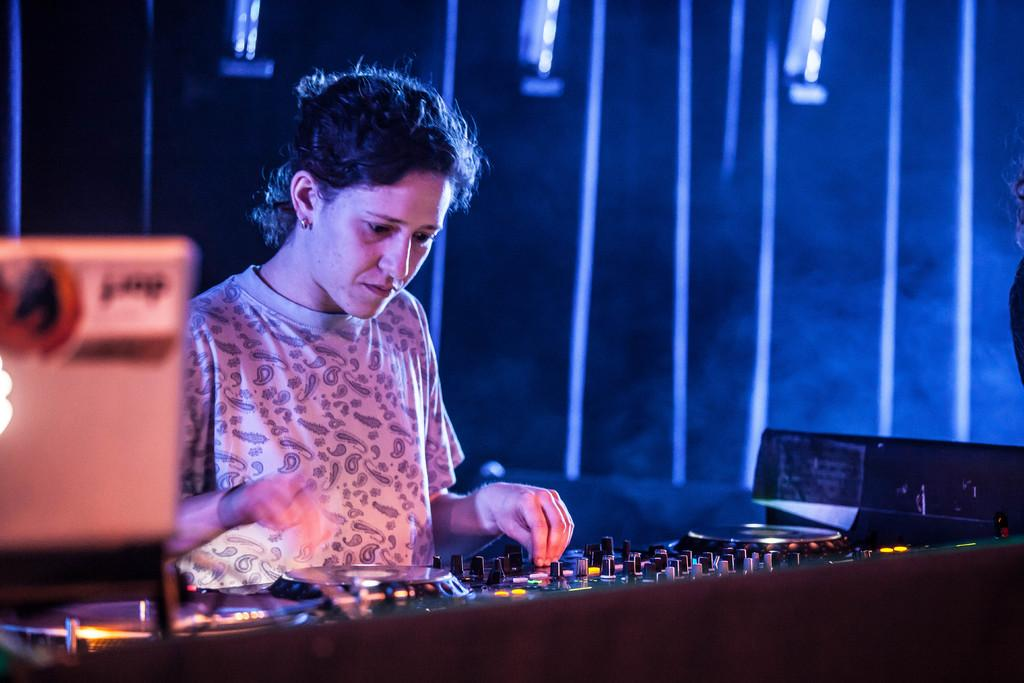Who is the main subject in the image? There is a lady in the image. What is the lady doing in the image? The lady is operating a musical instrument. Can you describe the background of the image? There is an object in the background of the image. What can be seen in terms of lighting in the image? Lights are visible in the image. What type of covering is present in the image? There is a curtain in the image. What type of event is the lady attending in the image? There is no indication of an event in the image; it simply shows a lady operating a musical instrument. How much wealth is visible in the image? There is no reference to wealth in the image; it focuses on the lady and her musical instrument. 